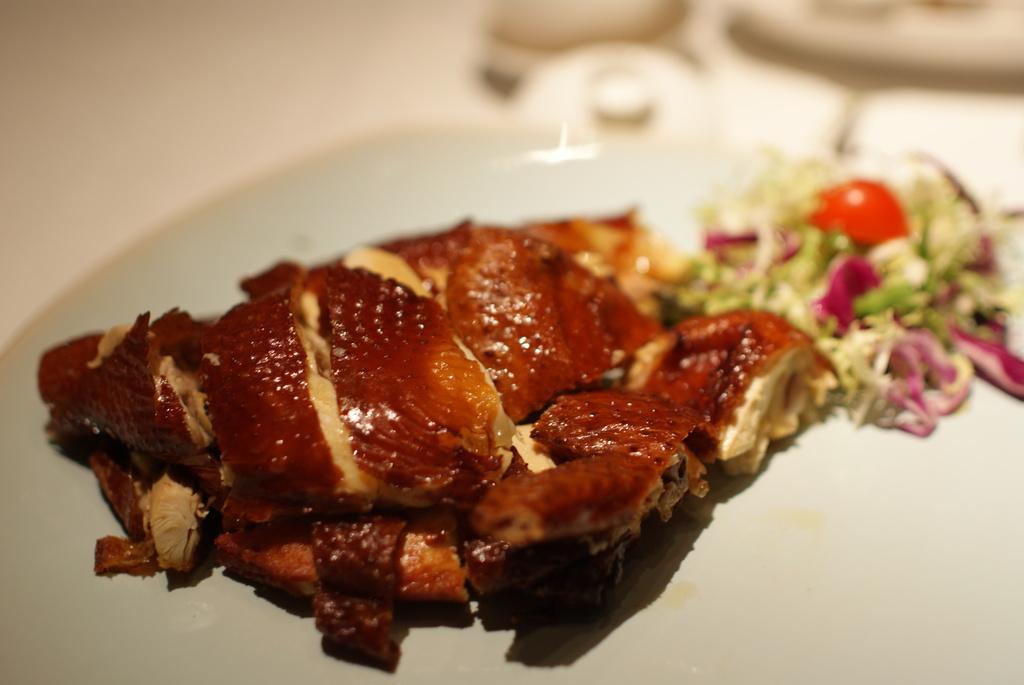Describe this image in one or two sentences. In this image we can see some food items on an object looks like a plate and a blurry background. 